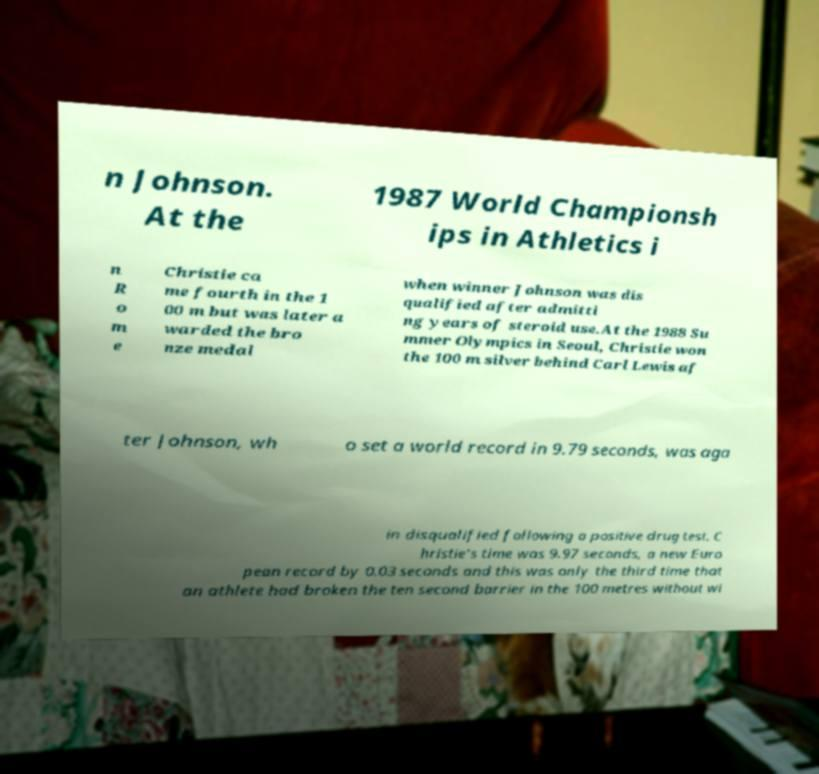Can you read and provide the text displayed in the image?This photo seems to have some interesting text. Can you extract and type it out for me? n Johnson. At the 1987 World Championsh ips in Athletics i n R o m e Christie ca me fourth in the 1 00 m but was later a warded the bro nze medal when winner Johnson was dis qualified after admitti ng years of steroid use.At the 1988 Su mmer Olympics in Seoul, Christie won the 100 m silver behind Carl Lewis af ter Johnson, wh o set a world record in 9.79 seconds, was aga in disqualified following a positive drug test. C hristie's time was 9.97 seconds, a new Euro pean record by 0.03 seconds and this was only the third time that an athlete had broken the ten second barrier in the 100 metres without wi 